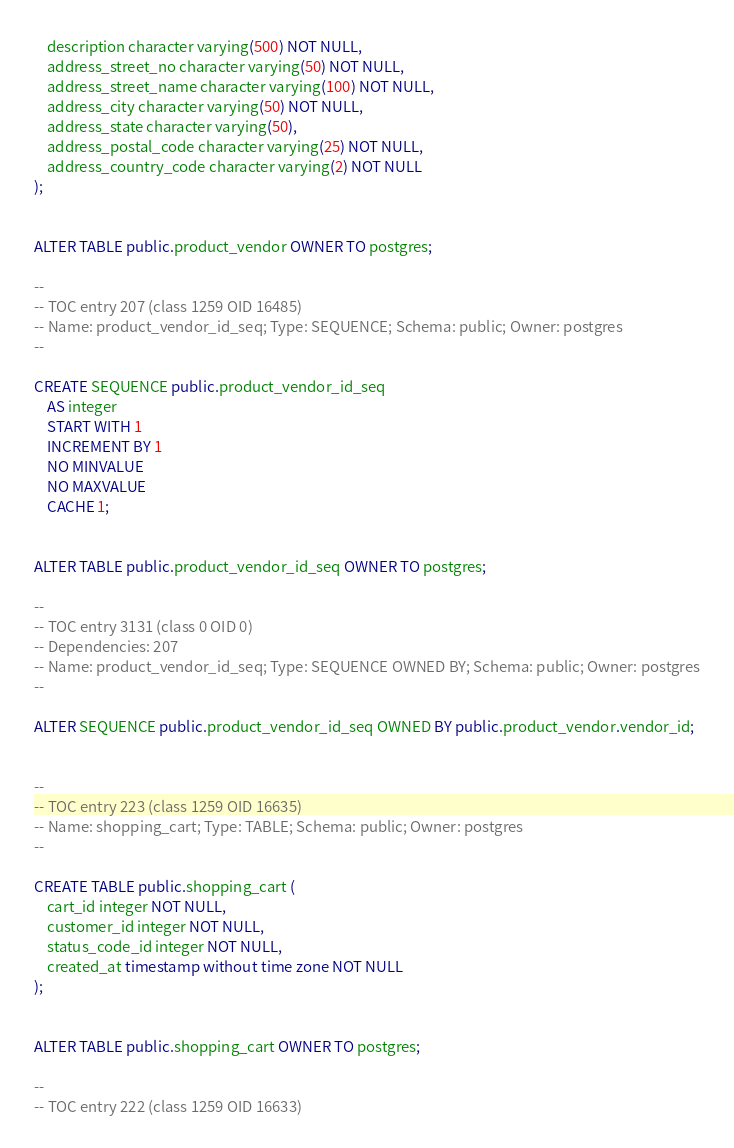<code> <loc_0><loc_0><loc_500><loc_500><_SQL_>    description character varying(500) NOT NULL,
    address_street_no character varying(50) NOT NULL,
    address_street_name character varying(100) NOT NULL,
    address_city character varying(50) NOT NULL,
    address_state character varying(50),
    address_postal_code character varying(25) NOT NULL,
    address_country_code character varying(2) NOT NULL
);


ALTER TABLE public.product_vendor OWNER TO postgres;

--
-- TOC entry 207 (class 1259 OID 16485)
-- Name: product_vendor_id_seq; Type: SEQUENCE; Schema: public; Owner: postgres
--

CREATE SEQUENCE public.product_vendor_id_seq
    AS integer
    START WITH 1
    INCREMENT BY 1
    NO MINVALUE
    NO MAXVALUE
    CACHE 1;


ALTER TABLE public.product_vendor_id_seq OWNER TO postgres;

--
-- TOC entry 3131 (class 0 OID 0)
-- Dependencies: 207
-- Name: product_vendor_id_seq; Type: SEQUENCE OWNED BY; Schema: public; Owner: postgres
--

ALTER SEQUENCE public.product_vendor_id_seq OWNED BY public.product_vendor.vendor_id;


--
-- TOC entry 223 (class 1259 OID 16635)
-- Name: shopping_cart; Type: TABLE; Schema: public; Owner: postgres
--

CREATE TABLE public.shopping_cart (
    cart_id integer NOT NULL,
    customer_id integer NOT NULL,
    status_code_id integer NOT NULL,
    created_at timestamp without time zone NOT NULL
);


ALTER TABLE public.shopping_cart OWNER TO postgres;

--
-- TOC entry 222 (class 1259 OID 16633)</code> 